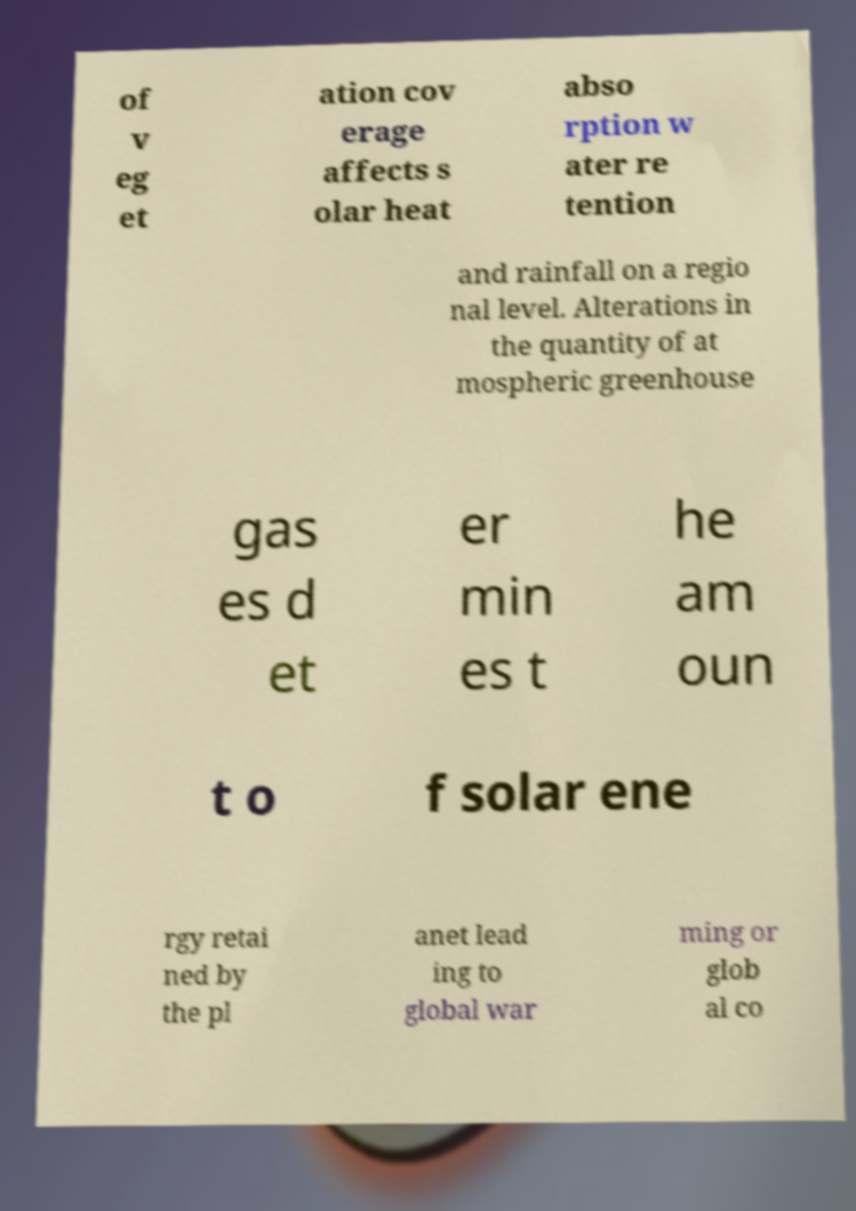Can you accurately transcribe the text from the provided image for me? of v eg et ation cov erage affects s olar heat abso rption w ater re tention and rainfall on a regio nal level. Alterations in the quantity of at mospheric greenhouse gas es d et er min es t he am oun t o f solar ene rgy retai ned by the pl anet lead ing to global war ming or glob al co 